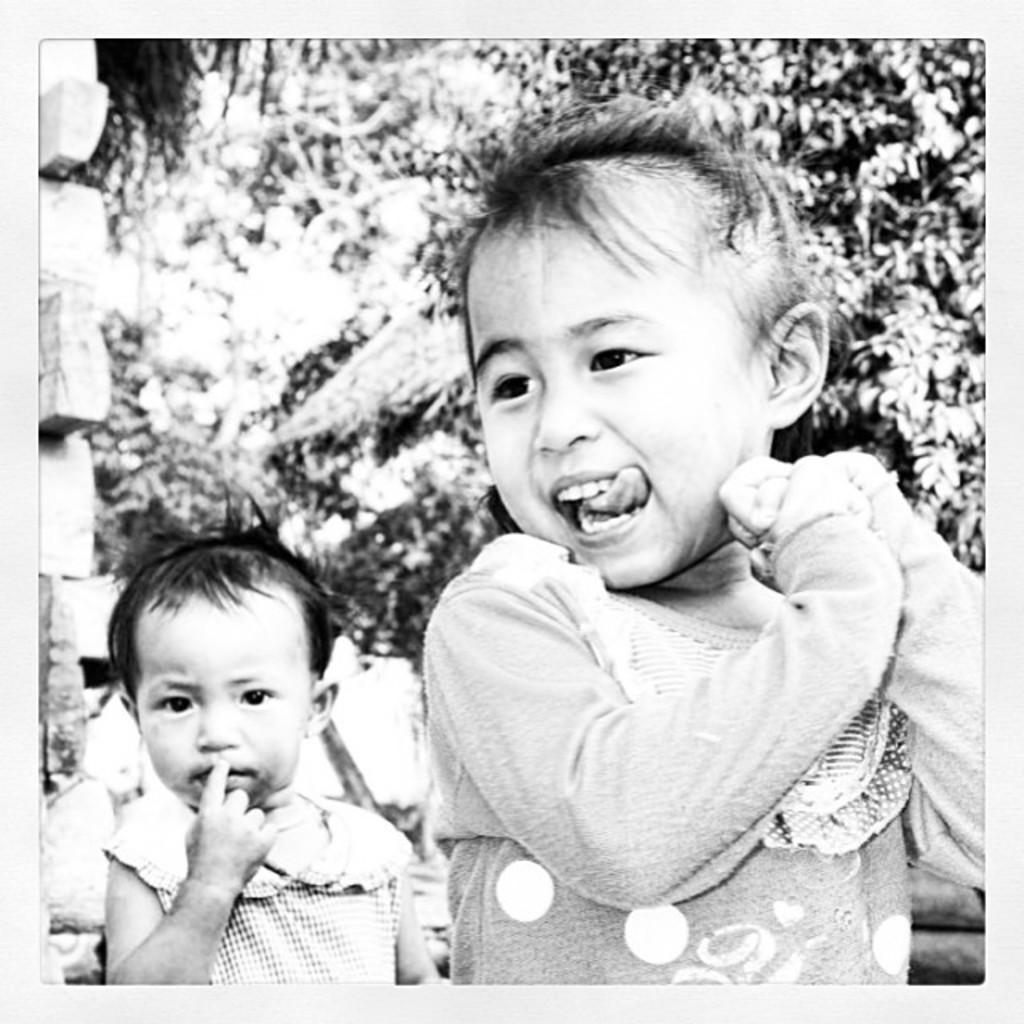What is the color scheme of the image? The image is black and white. How many people are in the image? There are two persons standing in the image. What can be seen in the background of the image? There are trees in the background of the image. What is the composition of the image like? There are objects truncated towards the left side of the image. What type of paper is visible in the image? There is no paper present in the image. Can you describe the view from the top of the trees in the image? The image does not provide a view from the top of the trees, as it is a still image of two persons standing with trees in the background. 